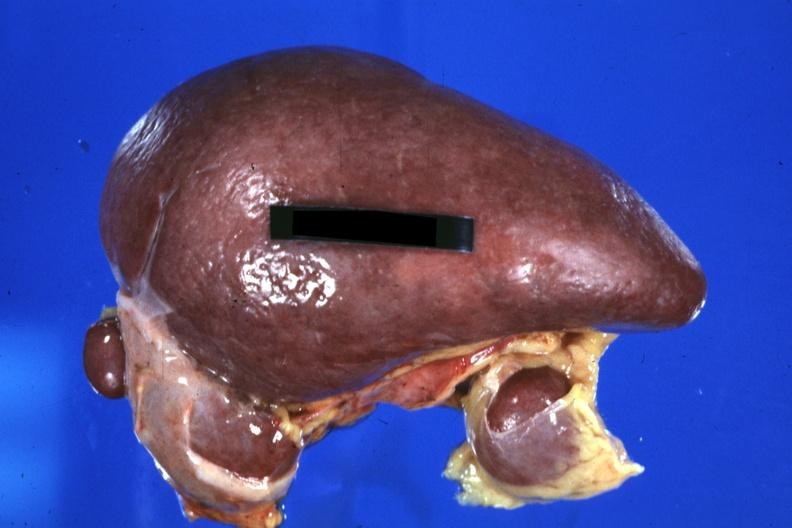how is spleen with three accessories 32yobf left isomerism and congenital heart disease?
Answer the question using a single word or phrase. Complex 